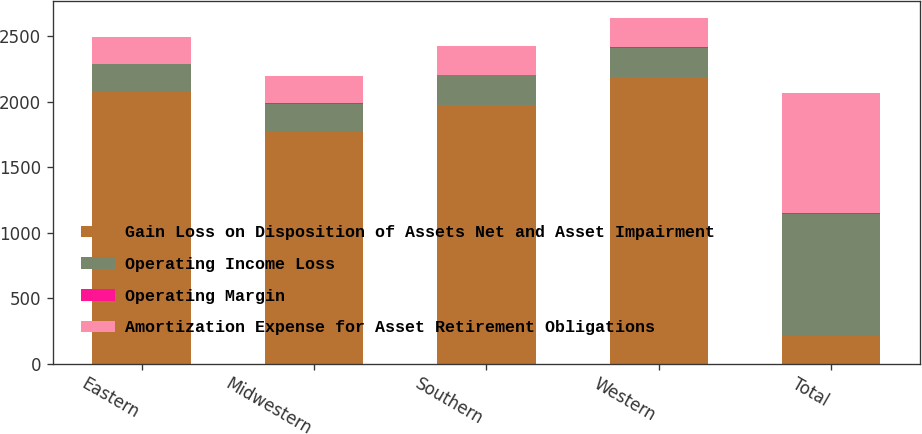<chart> <loc_0><loc_0><loc_500><loc_500><stacked_bar_chart><ecel><fcel>Eastern<fcel>Midwestern<fcel>Southern<fcel>Western<fcel>Total<nl><fcel>Gain Loss on Disposition of Assets Net and Asset Impairment<fcel>2075.5<fcel>1766.9<fcel>1977.3<fcel>2188.6<fcel>218.2<nl><fcel>Operating Income Loss<fcel>208.8<fcel>214.2<fcel>225.3<fcel>224.2<fcel>924.4<nl><fcel>Operating Margin<fcel>3.3<fcel>10.6<fcel>3.8<fcel>6<fcel>10.2<nl><fcel>Amortization Expense for Asset Retirement Obligations<fcel>205.5<fcel>203.6<fcel>221.5<fcel>218.2<fcel>914.2<nl></chart> 